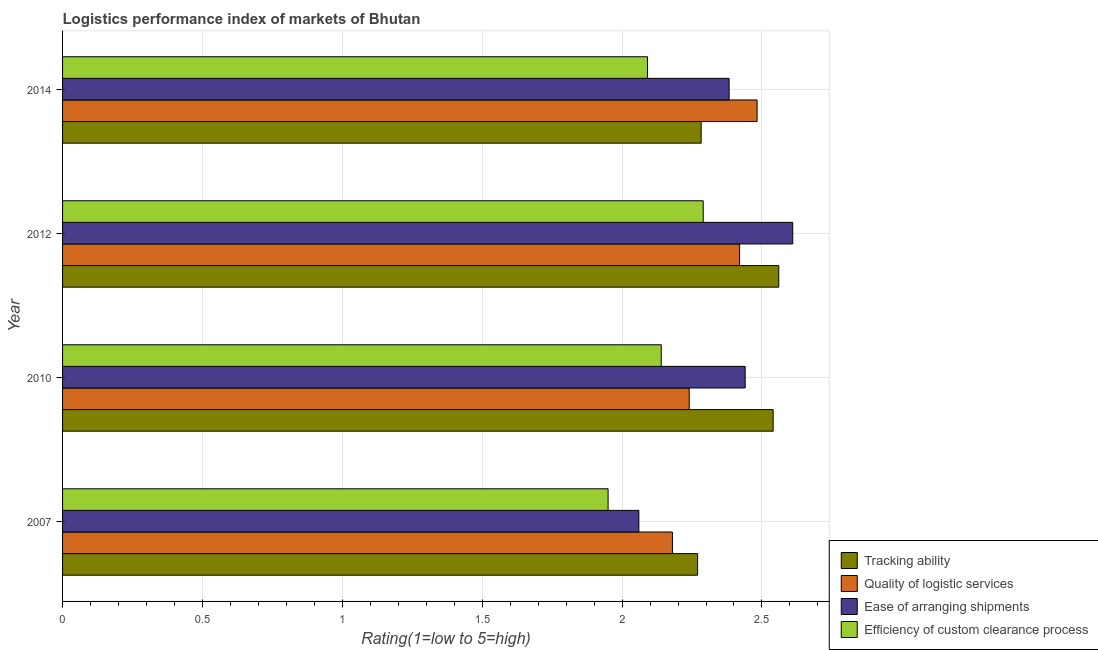How many groups of bars are there?
Keep it short and to the point. 4. Are the number of bars per tick equal to the number of legend labels?
Keep it short and to the point. Yes. Are the number of bars on each tick of the Y-axis equal?
Ensure brevity in your answer.  Yes. How many bars are there on the 4th tick from the top?
Provide a succinct answer. 4. What is the lpi rating of efficiency of custom clearance process in 2012?
Your answer should be compact. 2.29. Across all years, what is the maximum lpi rating of efficiency of custom clearance process?
Offer a very short reply. 2.29. Across all years, what is the minimum lpi rating of quality of logistic services?
Offer a very short reply. 2.18. In which year was the lpi rating of tracking ability minimum?
Make the answer very short. 2007. What is the total lpi rating of efficiency of custom clearance process in the graph?
Make the answer very short. 8.47. What is the difference between the lpi rating of efficiency of custom clearance process in 2007 and that in 2014?
Give a very brief answer. -0.14. What is the difference between the lpi rating of quality of logistic services in 2010 and the lpi rating of tracking ability in 2014?
Make the answer very short. -0.04. What is the average lpi rating of ease of arranging shipments per year?
Keep it short and to the point. 2.37. In the year 2007, what is the difference between the lpi rating of tracking ability and lpi rating of efficiency of custom clearance process?
Provide a short and direct response. 0.32. What is the ratio of the lpi rating of efficiency of custom clearance process in 2010 to that in 2012?
Provide a succinct answer. 0.93. Is the lpi rating of efficiency of custom clearance process in 2010 less than that in 2014?
Provide a succinct answer. No. What is the difference between the highest and the second highest lpi rating of efficiency of custom clearance process?
Offer a very short reply. 0.15. What is the difference between the highest and the lowest lpi rating of efficiency of custom clearance process?
Make the answer very short. 0.34. In how many years, is the lpi rating of ease of arranging shipments greater than the average lpi rating of ease of arranging shipments taken over all years?
Keep it short and to the point. 3. What does the 1st bar from the top in 2014 represents?
Your answer should be very brief. Efficiency of custom clearance process. What does the 4th bar from the bottom in 2014 represents?
Provide a succinct answer. Efficiency of custom clearance process. How many bars are there?
Your response must be concise. 16. Are all the bars in the graph horizontal?
Make the answer very short. Yes. Are the values on the major ticks of X-axis written in scientific E-notation?
Your response must be concise. No. Does the graph contain any zero values?
Offer a terse response. No. Does the graph contain grids?
Ensure brevity in your answer.  Yes. What is the title of the graph?
Make the answer very short. Logistics performance index of markets of Bhutan. Does "Permission" appear as one of the legend labels in the graph?
Your answer should be compact. No. What is the label or title of the X-axis?
Give a very brief answer. Rating(1=low to 5=high). What is the Rating(1=low to 5=high) in Tracking ability in 2007?
Offer a very short reply. 2.27. What is the Rating(1=low to 5=high) in Quality of logistic services in 2007?
Make the answer very short. 2.18. What is the Rating(1=low to 5=high) of Ease of arranging shipments in 2007?
Offer a terse response. 2.06. What is the Rating(1=low to 5=high) of Efficiency of custom clearance process in 2007?
Provide a short and direct response. 1.95. What is the Rating(1=low to 5=high) in Tracking ability in 2010?
Provide a succinct answer. 2.54. What is the Rating(1=low to 5=high) in Quality of logistic services in 2010?
Provide a short and direct response. 2.24. What is the Rating(1=low to 5=high) in Ease of arranging shipments in 2010?
Your response must be concise. 2.44. What is the Rating(1=low to 5=high) of Efficiency of custom clearance process in 2010?
Your answer should be very brief. 2.14. What is the Rating(1=low to 5=high) of Tracking ability in 2012?
Ensure brevity in your answer.  2.56. What is the Rating(1=low to 5=high) of Quality of logistic services in 2012?
Offer a terse response. 2.42. What is the Rating(1=low to 5=high) in Ease of arranging shipments in 2012?
Make the answer very short. 2.61. What is the Rating(1=low to 5=high) in Efficiency of custom clearance process in 2012?
Your answer should be compact. 2.29. What is the Rating(1=low to 5=high) of Tracking ability in 2014?
Give a very brief answer. 2.28. What is the Rating(1=low to 5=high) of Quality of logistic services in 2014?
Offer a very short reply. 2.48. What is the Rating(1=low to 5=high) in Ease of arranging shipments in 2014?
Offer a terse response. 2.38. What is the Rating(1=low to 5=high) of Efficiency of custom clearance process in 2014?
Make the answer very short. 2.09. Across all years, what is the maximum Rating(1=low to 5=high) in Tracking ability?
Ensure brevity in your answer.  2.56. Across all years, what is the maximum Rating(1=low to 5=high) in Quality of logistic services?
Your response must be concise. 2.48. Across all years, what is the maximum Rating(1=low to 5=high) in Ease of arranging shipments?
Give a very brief answer. 2.61. Across all years, what is the maximum Rating(1=low to 5=high) of Efficiency of custom clearance process?
Make the answer very short. 2.29. Across all years, what is the minimum Rating(1=low to 5=high) of Tracking ability?
Your answer should be very brief. 2.27. Across all years, what is the minimum Rating(1=low to 5=high) in Quality of logistic services?
Offer a terse response. 2.18. Across all years, what is the minimum Rating(1=low to 5=high) in Ease of arranging shipments?
Provide a succinct answer. 2.06. Across all years, what is the minimum Rating(1=low to 5=high) of Efficiency of custom clearance process?
Your answer should be very brief. 1.95. What is the total Rating(1=low to 5=high) of Tracking ability in the graph?
Your answer should be compact. 9.65. What is the total Rating(1=low to 5=high) in Quality of logistic services in the graph?
Give a very brief answer. 9.32. What is the total Rating(1=low to 5=high) of Ease of arranging shipments in the graph?
Your answer should be very brief. 9.49. What is the total Rating(1=low to 5=high) in Efficiency of custom clearance process in the graph?
Your answer should be compact. 8.47. What is the difference between the Rating(1=low to 5=high) in Tracking ability in 2007 and that in 2010?
Provide a short and direct response. -0.27. What is the difference between the Rating(1=low to 5=high) of Quality of logistic services in 2007 and that in 2010?
Offer a terse response. -0.06. What is the difference between the Rating(1=low to 5=high) of Ease of arranging shipments in 2007 and that in 2010?
Ensure brevity in your answer.  -0.38. What is the difference between the Rating(1=low to 5=high) in Efficiency of custom clearance process in 2007 and that in 2010?
Your answer should be compact. -0.19. What is the difference between the Rating(1=low to 5=high) of Tracking ability in 2007 and that in 2012?
Provide a succinct answer. -0.29. What is the difference between the Rating(1=low to 5=high) of Quality of logistic services in 2007 and that in 2012?
Keep it short and to the point. -0.24. What is the difference between the Rating(1=low to 5=high) of Ease of arranging shipments in 2007 and that in 2012?
Keep it short and to the point. -0.55. What is the difference between the Rating(1=low to 5=high) of Efficiency of custom clearance process in 2007 and that in 2012?
Your answer should be compact. -0.34. What is the difference between the Rating(1=low to 5=high) in Tracking ability in 2007 and that in 2014?
Offer a terse response. -0.01. What is the difference between the Rating(1=low to 5=high) of Quality of logistic services in 2007 and that in 2014?
Offer a very short reply. -0.3. What is the difference between the Rating(1=low to 5=high) of Ease of arranging shipments in 2007 and that in 2014?
Give a very brief answer. -0.32. What is the difference between the Rating(1=low to 5=high) in Efficiency of custom clearance process in 2007 and that in 2014?
Offer a very short reply. -0.14. What is the difference between the Rating(1=low to 5=high) in Tracking ability in 2010 and that in 2012?
Give a very brief answer. -0.02. What is the difference between the Rating(1=low to 5=high) of Quality of logistic services in 2010 and that in 2012?
Make the answer very short. -0.18. What is the difference between the Rating(1=low to 5=high) of Ease of arranging shipments in 2010 and that in 2012?
Your response must be concise. -0.17. What is the difference between the Rating(1=low to 5=high) of Tracking ability in 2010 and that in 2014?
Your answer should be compact. 0.26. What is the difference between the Rating(1=low to 5=high) in Quality of logistic services in 2010 and that in 2014?
Give a very brief answer. -0.24. What is the difference between the Rating(1=low to 5=high) in Ease of arranging shipments in 2010 and that in 2014?
Ensure brevity in your answer.  0.06. What is the difference between the Rating(1=low to 5=high) in Efficiency of custom clearance process in 2010 and that in 2014?
Ensure brevity in your answer.  0.05. What is the difference between the Rating(1=low to 5=high) in Tracking ability in 2012 and that in 2014?
Provide a short and direct response. 0.28. What is the difference between the Rating(1=low to 5=high) of Quality of logistic services in 2012 and that in 2014?
Ensure brevity in your answer.  -0.06. What is the difference between the Rating(1=low to 5=high) of Ease of arranging shipments in 2012 and that in 2014?
Your response must be concise. 0.23. What is the difference between the Rating(1=low to 5=high) in Efficiency of custom clearance process in 2012 and that in 2014?
Provide a short and direct response. 0.2. What is the difference between the Rating(1=low to 5=high) of Tracking ability in 2007 and the Rating(1=low to 5=high) of Quality of logistic services in 2010?
Give a very brief answer. 0.03. What is the difference between the Rating(1=low to 5=high) of Tracking ability in 2007 and the Rating(1=low to 5=high) of Ease of arranging shipments in 2010?
Offer a very short reply. -0.17. What is the difference between the Rating(1=low to 5=high) in Tracking ability in 2007 and the Rating(1=low to 5=high) in Efficiency of custom clearance process in 2010?
Your response must be concise. 0.13. What is the difference between the Rating(1=low to 5=high) in Quality of logistic services in 2007 and the Rating(1=low to 5=high) in Ease of arranging shipments in 2010?
Your answer should be very brief. -0.26. What is the difference between the Rating(1=low to 5=high) in Quality of logistic services in 2007 and the Rating(1=low to 5=high) in Efficiency of custom clearance process in 2010?
Provide a short and direct response. 0.04. What is the difference between the Rating(1=low to 5=high) in Ease of arranging shipments in 2007 and the Rating(1=low to 5=high) in Efficiency of custom clearance process in 2010?
Ensure brevity in your answer.  -0.08. What is the difference between the Rating(1=low to 5=high) of Tracking ability in 2007 and the Rating(1=low to 5=high) of Ease of arranging shipments in 2012?
Offer a terse response. -0.34. What is the difference between the Rating(1=low to 5=high) of Tracking ability in 2007 and the Rating(1=low to 5=high) of Efficiency of custom clearance process in 2012?
Keep it short and to the point. -0.02. What is the difference between the Rating(1=low to 5=high) of Quality of logistic services in 2007 and the Rating(1=low to 5=high) of Ease of arranging shipments in 2012?
Your response must be concise. -0.43. What is the difference between the Rating(1=low to 5=high) of Quality of logistic services in 2007 and the Rating(1=low to 5=high) of Efficiency of custom clearance process in 2012?
Give a very brief answer. -0.11. What is the difference between the Rating(1=low to 5=high) in Ease of arranging shipments in 2007 and the Rating(1=low to 5=high) in Efficiency of custom clearance process in 2012?
Your answer should be compact. -0.23. What is the difference between the Rating(1=low to 5=high) of Tracking ability in 2007 and the Rating(1=low to 5=high) of Quality of logistic services in 2014?
Your answer should be very brief. -0.21. What is the difference between the Rating(1=low to 5=high) of Tracking ability in 2007 and the Rating(1=low to 5=high) of Ease of arranging shipments in 2014?
Keep it short and to the point. -0.11. What is the difference between the Rating(1=low to 5=high) in Tracking ability in 2007 and the Rating(1=low to 5=high) in Efficiency of custom clearance process in 2014?
Your answer should be very brief. 0.18. What is the difference between the Rating(1=low to 5=high) in Quality of logistic services in 2007 and the Rating(1=low to 5=high) in Ease of arranging shipments in 2014?
Make the answer very short. -0.2. What is the difference between the Rating(1=low to 5=high) in Quality of logistic services in 2007 and the Rating(1=low to 5=high) in Efficiency of custom clearance process in 2014?
Offer a terse response. 0.09. What is the difference between the Rating(1=low to 5=high) of Ease of arranging shipments in 2007 and the Rating(1=low to 5=high) of Efficiency of custom clearance process in 2014?
Your answer should be very brief. -0.03. What is the difference between the Rating(1=low to 5=high) of Tracking ability in 2010 and the Rating(1=low to 5=high) of Quality of logistic services in 2012?
Keep it short and to the point. 0.12. What is the difference between the Rating(1=low to 5=high) of Tracking ability in 2010 and the Rating(1=low to 5=high) of Ease of arranging shipments in 2012?
Offer a very short reply. -0.07. What is the difference between the Rating(1=low to 5=high) in Tracking ability in 2010 and the Rating(1=low to 5=high) in Efficiency of custom clearance process in 2012?
Ensure brevity in your answer.  0.25. What is the difference between the Rating(1=low to 5=high) in Quality of logistic services in 2010 and the Rating(1=low to 5=high) in Ease of arranging shipments in 2012?
Ensure brevity in your answer.  -0.37. What is the difference between the Rating(1=low to 5=high) of Quality of logistic services in 2010 and the Rating(1=low to 5=high) of Efficiency of custom clearance process in 2012?
Provide a short and direct response. -0.05. What is the difference between the Rating(1=low to 5=high) of Ease of arranging shipments in 2010 and the Rating(1=low to 5=high) of Efficiency of custom clearance process in 2012?
Your answer should be very brief. 0.15. What is the difference between the Rating(1=low to 5=high) in Tracking ability in 2010 and the Rating(1=low to 5=high) in Quality of logistic services in 2014?
Keep it short and to the point. 0.06. What is the difference between the Rating(1=low to 5=high) of Tracking ability in 2010 and the Rating(1=low to 5=high) of Ease of arranging shipments in 2014?
Offer a terse response. 0.16. What is the difference between the Rating(1=low to 5=high) in Tracking ability in 2010 and the Rating(1=low to 5=high) in Efficiency of custom clearance process in 2014?
Ensure brevity in your answer.  0.45. What is the difference between the Rating(1=low to 5=high) of Quality of logistic services in 2010 and the Rating(1=low to 5=high) of Ease of arranging shipments in 2014?
Ensure brevity in your answer.  -0.14. What is the difference between the Rating(1=low to 5=high) of Quality of logistic services in 2010 and the Rating(1=low to 5=high) of Efficiency of custom clearance process in 2014?
Provide a succinct answer. 0.15. What is the difference between the Rating(1=low to 5=high) of Ease of arranging shipments in 2010 and the Rating(1=low to 5=high) of Efficiency of custom clearance process in 2014?
Give a very brief answer. 0.35. What is the difference between the Rating(1=low to 5=high) of Tracking ability in 2012 and the Rating(1=low to 5=high) of Quality of logistic services in 2014?
Offer a terse response. 0.08. What is the difference between the Rating(1=low to 5=high) in Tracking ability in 2012 and the Rating(1=low to 5=high) in Ease of arranging shipments in 2014?
Make the answer very short. 0.18. What is the difference between the Rating(1=low to 5=high) in Tracking ability in 2012 and the Rating(1=low to 5=high) in Efficiency of custom clearance process in 2014?
Your answer should be compact. 0.47. What is the difference between the Rating(1=low to 5=high) of Quality of logistic services in 2012 and the Rating(1=low to 5=high) of Ease of arranging shipments in 2014?
Provide a succinct answer. 0.04. What is the difference between the Rating(1=low to 5=high) of Quality of logistic services in 2012 and the Rating(1=low to 5=high) of Efficiency of custom clearance process in 2014?
Provide a short and direct response. 0.33. What is the difference between the Rating(1=low to 5=high) in Ease of arranging shipments in 2012 and the Rating(1=low to 5=high) in Efficiency of custom clearance process in 2014?
Your answer should be very brief. 0.52. What is the average Rating(1=low to 5=high) in Tracking ability per year?
Your answer should be very brief. 2.41. What is the average Rating(1=low to 5=high) in Quality of logistic services per year?
Your response must be concise. 2.33. What is the average Rating(1=low to 5=high) of Ease of arranging shipments per year?
Keep it short and to the point. 2.37. What is the average Rating(1=low to 5=high) in Efficiency of custom clearance process per year?
Offer a terse response. 2.12. In the year 2007, what is the difference between the Rating(1=low to 5=high) of Tracking ability and Rating(1=low to 5=high) of Quality of logistic services?
Make the answer very short. 0.09. In the year 2007, what is the difference between the Rating(1=low to 5=high) in Tracking ability and Rating(1=low to 5=high) in Ease of arranging shipments?
Ensure brevity in your answer.  0.21. In the year 2007, what is the difference between the Rating(1=low to 5=high) of Tracking ability and Rating(1=low to 5=high) of Efficiency of custom clearance process?
Offer a very short reply. 0.32. In the year 2007, what is the difference between the Rating(1=low to 5=high) of Quality of logistic services and Rating(1=low to 5=high) of Ease of arranging shipments?
Offer a terse response. 0.12. In the year 2007, what is the difference between the Rating(1=low to 5=high) in Quality of logistic services and Rating(1=low to 5=high) in Efficiency of custom clearance process?
Offer a very short reply. 0.23. In the year 2007, what is the difference between the Rating(1=low to 5=high) of Ease of arranging shipments and Rating(1=low to 5=high) of Efficiency of custom clearance process?
Offer a terse response. 0.11. In the year 2010, what is the difference between the Rating(1=low to 5=high) in Tracking ability and Rating(1=low to 5=high) in Quality of logistic services?
Your answer should be compact. 0.3. In the year 2010, what is the difference between the Rating(1=low to 5=high) of Tracking ability and Rating(1=low to 5=high) of Ease of arranging shipments?
Your answer should be compact. 0.1. In the year 2010, what is the difference between the Rating(1=low to 5=high) in Tracking ability and Rating(1=low to 5=high) in Efficiency of custom clearance process?
Make the answer very short. 0.4. In the year 2010, what is the difference between the Rating(1=low to 5=high) in Ease of arranging shipments and Rating(1=low to 5=high) in Efficiency of custom clearance process?
Your answer should be compact. 0.3. In the year 2012, what is the difference between the Rating(1=low to 5=high) of Tracking ability and Rating(1=low to 5=high) of Quality of logistic services?
Offer a terse response. 0.14. In the year 2012, what is the difference between the Rating(1=low to 5=high) in Tracking ability and Rating(1=low to 5=high) in Efficiency of custom clearance process?
Your answer should be compact. 0.27. In the year 2012, what is the difference between the Rating(1=low to 5=high) in Quality of logistic services and Rating(1=low to 5=high) in Ease of arranging shipments?
Your answer should be compact. -0.19. In the year 2012, what is the difference between the Rating(1=low to 5=high) in Quality of logistic services and Rating(1=low to 5=high) in Efficiency of custom clearance process?
Your answer should be very brief. 0.13. In the year 2012, what is the difference between the Rating(1=low to 5=high) in Ease of arranging shipments and Rating(1=low to 5=high) in Efficiency of custom clearance process?
Your response must be concise. 0.32. In the year 2014, what is the difference between the Rating(1=low to 5=high) in Tracking ability and Rating(1=low to 5=high) in Ease of arranging shipments?
Your answer should be very brief. -0.1. In the year 2014, what is the difference between the Rating(1=low to 5=high) in Tracking ability and Rating(1=low to 5=high) in Efficiency of custom clearance process?
Keep it short and to the point. 0.19. In the year 2014, what is the difference between the Rating(1=low to 5=high) of Quality of logistic services and Rating(1=low to 5=high) of Ease of arranging shipments?
Ensure brevity in your answer.  0.1. In the year 2014, what is the difference between the Rating(1=low to 5=high) in Quality of logistic services and Rating(1=low to 5=high) in Efficiency of custom clearance process?
Offer a terse response. 0.39. In the year 2014, what is the difference between the Rating(1=low to 5=high) of Ease of arranging shipments and Rating(1=low to 5=high) of Efficiency of custom clearance process?
Give a very brief answer. 0.29. What is the ratio of the Rating(1=low to 5=high) of Tracking ability in 2007 to that in 2010?
Offer a terse response. 0.89. What is the ratio of the Rating(1=low to 5=high) in Quality of logistic services in 2007 to that in 2010?
Offer a very short reply. 0.97. What is the ratio of the Rating(1=low to 5=high) in Ease of arranging shipments in 2007 to that in 2010?
Make the answer very short. 0.84. What is the ratio of the Rating(1=low to 5=high) in Efficiency of custom clearance process in 2007 to that in 2010?
Provide a short and direct response. 0.91. What is the ratio of the Rating(1=low to 5=high) of Tracking ability in 2007 to that in 2012?
Your answer should be compact. 0.89. What is the ratio of the Rating(1=low to 5=high) in Quality of logistic services in 2007 to that in 2012?
Provide a succinct answer. 0.9. What is the ratio of the Rating(1=low to 5=high) of Ease of arranging shipments in 2007 to that in 2012?
Provide a short and direct response. 0.79. What is the ratio of the Rating(1=low to 5=high) in Efficiency of custom clearance process in 2007 to that in 2012?
Provide a succinct answer. 0.85. What is the ratio of the Rating(1=low to 5=high) of Quality of logistic services in 2007 to that in 2014?
Provide a short and direct response. 0.88. What is the ratio of the Rating(1=low to 5=high) in Ease of arranging shipments in 2007 to that in 2014?
Offer a very short reply. 0.86. What is the ratio of the Rating(1=low to 5=high) in Efficiency of custom clearance process in 2007 to that in 2014?
Make the answer very short. 0.93. What is the ratio of the Rating(1=low to 5=high) in Tracking ability in 2010 to that in 2012?
Your response must be concise. 0.99. What is the ratio of the Rating(1=low to 5=high) in Quality of logistic services in 2010 to that in 2012?
Your answer should be compact. 0.93. What is the ratio of the Rating(1=low to 5=high) in Ease of arranging shipments in 2010 to that in 2012?
Keep it short and to the point. 0.93. What is the ratio of the Rating(1=low to 5=high) of Efficiency of custom clearance process in 2010 to that in 2012?
Keep it short and to the point. 0.93. What is the ratio of the Rating(1=low to 5=high) in Tracking ability in 2010 to that in 2014?
Your answer should be very brief. 1.11. What is the ratio of the Rating(1=low to 5=high) in Quality of logistic services in 2010 to that in 2014?
Provide a short and direct response. 0.9. What is the ratio of the Rating(1=low to 5=high) in Ease of arranging shipments in 2010 to that in 2014?
Provide a succinct answer. 1.02. What is the ratio of the Rating(1=low to 5=high) in Efficiency of custom clearance process in 2010 to that in 2014?
Keep it short and to the point. 1.02. What is the ratio of the Rating(1=low to 5=high) of Tracking ability in 2012 to that in 2014?
Keep it short and to the point. 1.12. What is the ratio of the Rating(1=low to 5=high) in Quality of logistic services in 2012 to that in 2014?
Your response must be concise. 0.97. What is the ratio of the Rating(1=low to 5=high) in Ease of arranging shipments in 2012 to that in 2014?
Make the answer very short. 1.1. What is the ratio of the Rating(1=low to 5=high) of Efficiency of custom clearance process in 2012 to that in 2014?
Keep it short and to the point. 1.1. What is the difference between the highest and the second highest Rating(1=low to 5=high) in Quality of logistic services?
Offer a very short reply. 0.06. What is the difference between the highest and the second highest Rating(1=low to 5=high) in Ease of arranging shipments?
Provide a succinct answer. 0.17. What is the difference between the highest and the second highest Rating(1=low to 5=high) of Efficiency of custom clearance process?
Make the answer very short. 0.15. What is the difference between the highest and the lowest Rating(1=low to 5=high) in Tracking ability?
Offer a very short reply. 0.29. What is the difference between the highest and the lowest Rating(1=low to 5=high) in Quality of logistic services?
Provide a short and direct response. 0.3. What is the difference between the highest and the lowest Rating(1=low to 5=high) of Ease of arranging shipments?
Your answer should be very brief. 0.55. What is the difference between the highest and the lowest Rating(1=low to 5=high) of Efficiency of custom clearance process?
Make the answer very short. 0.34. 